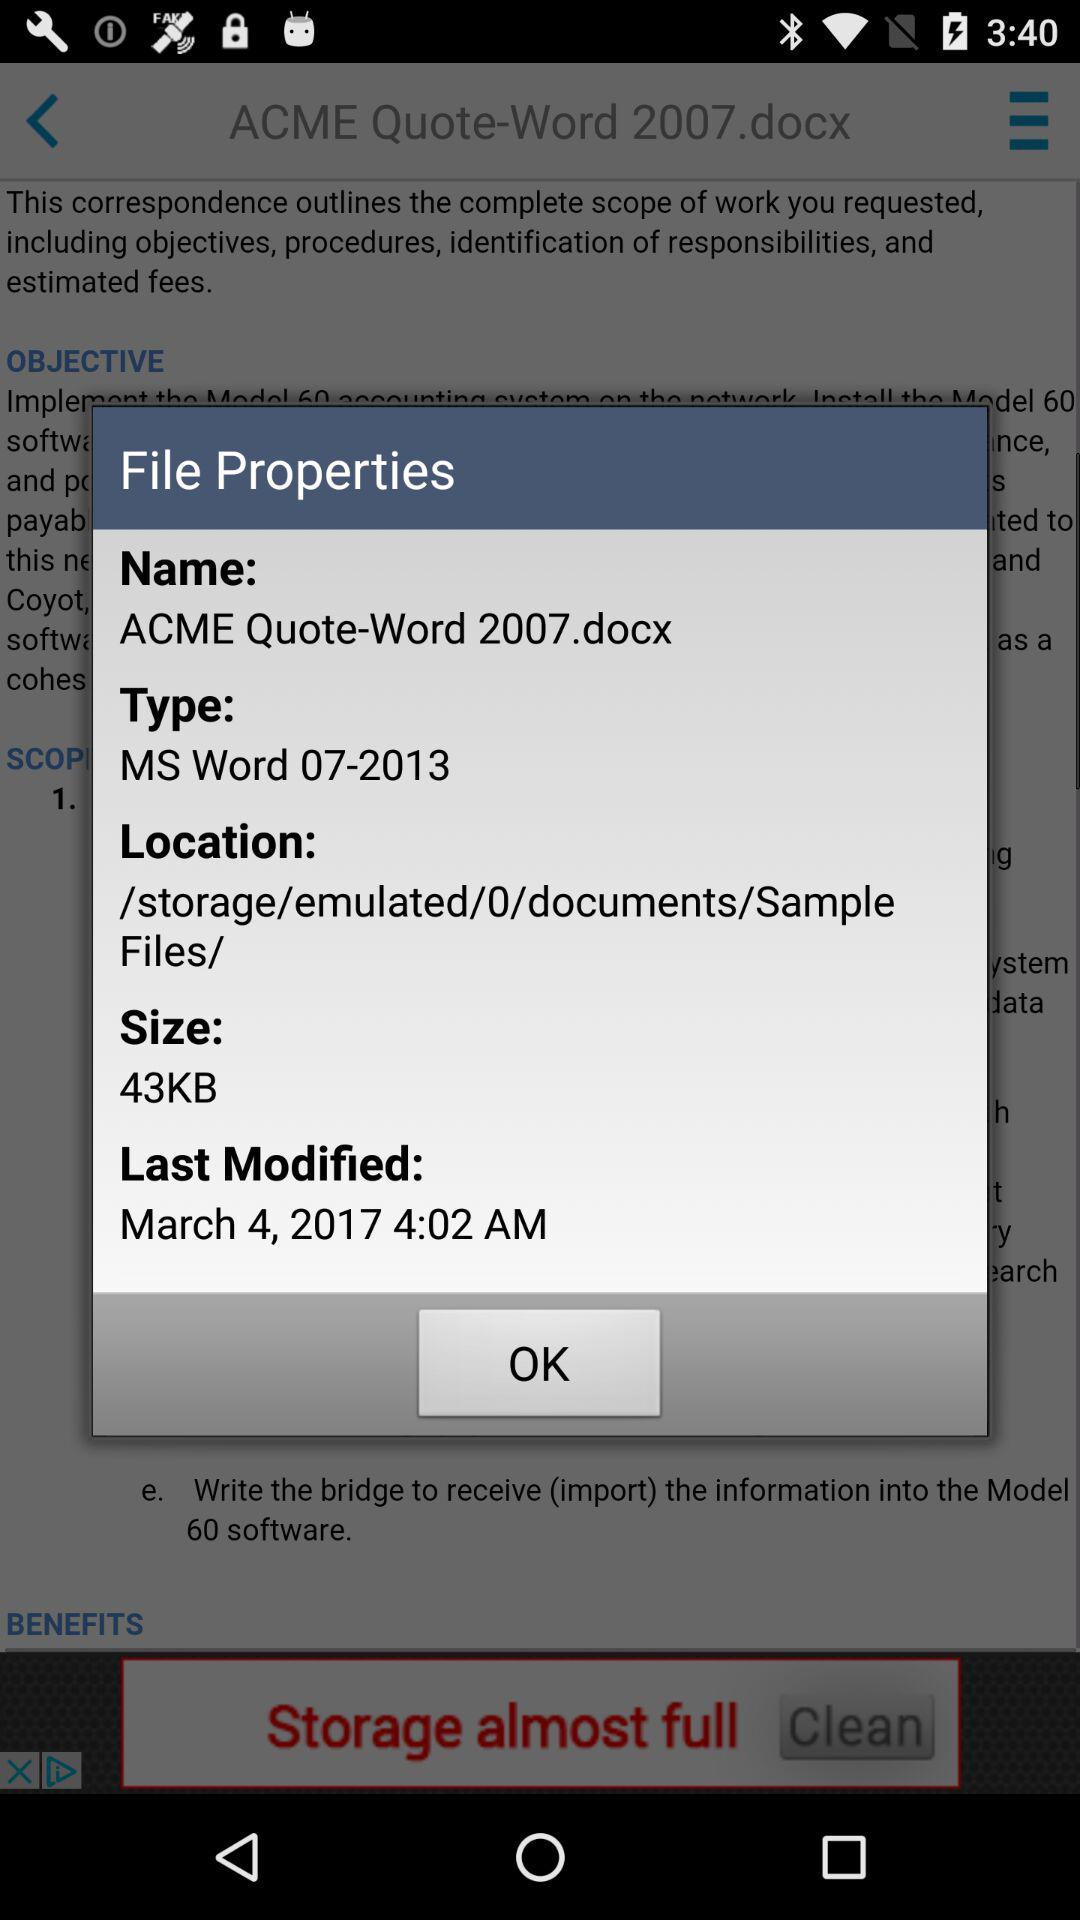What is last modified time? The last modified time is 4:02 AM. 